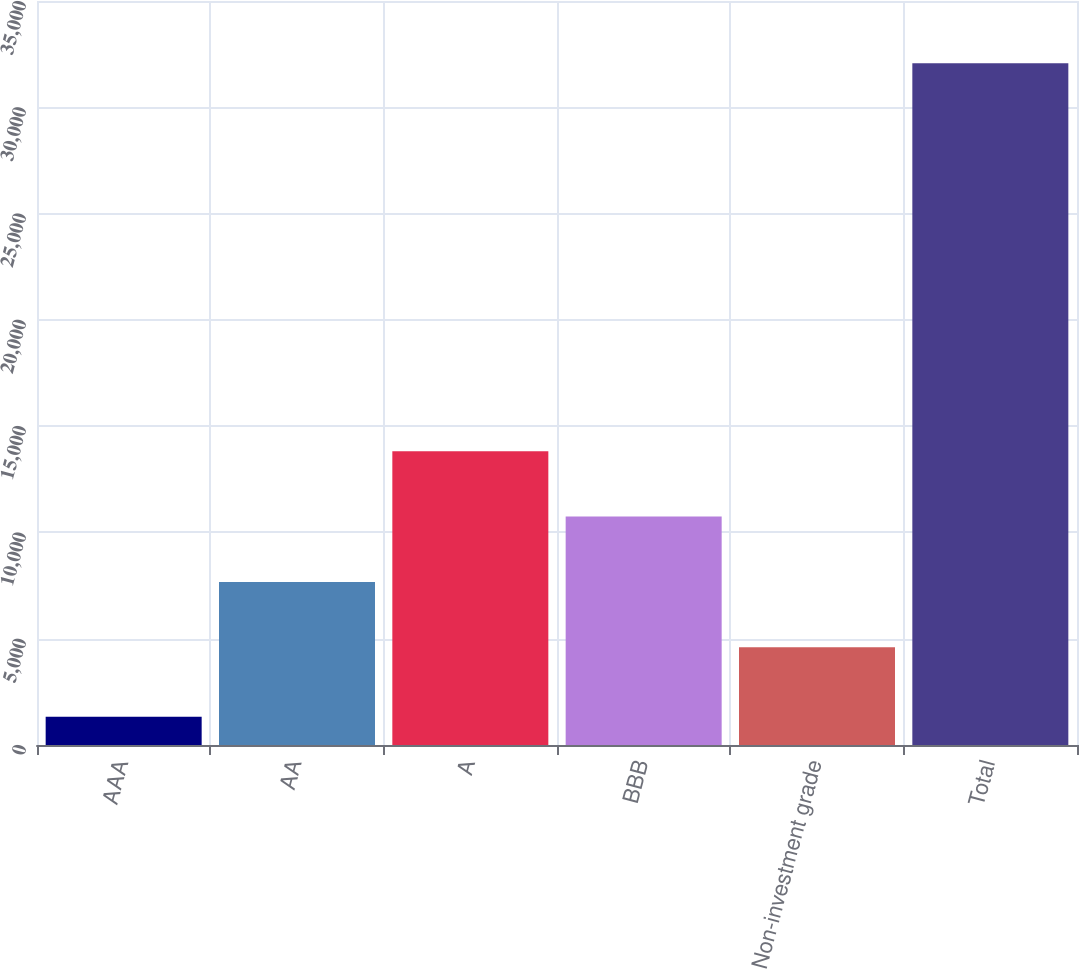Convert chart. <chart><loc_0><loc_0><loc_500><loc_500><bar_chart><fcel>AAA<fcel>AA<fcel>A<fcel>BBB<fcel>Non-investment grade<fcel>Total<nl><fcel>1330<fcel>7672.1<fcel>13820.3<fcel>10746.2<fcel>4598<fcel>32071<nl></chart> 